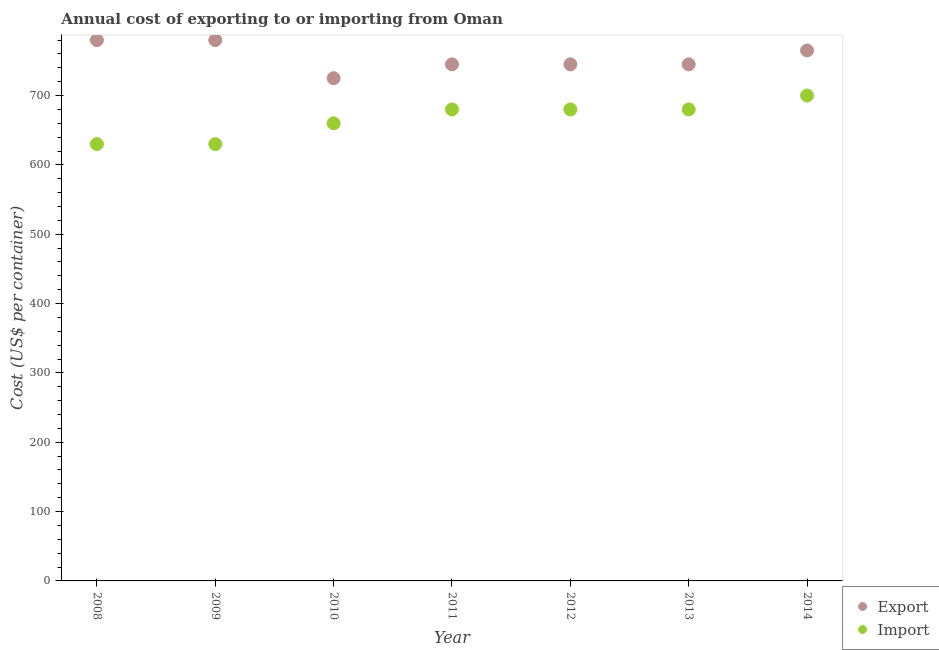How many different coloured dotlines are there?
Offer a very short reply. 2. Is the number of dotlines equal to the number of legend labels?
Your answer should be very brief. Yes. What is the export cost in 2012?
Your response must be concise. 745. Across all years, what is the maximum import cost?
Keep it short and to the point. 700. Across all years, what is the minimum import cost?
Ensure brevity in your answer.  630. In which year was the export cost maximum?
Provide a short and direct response. 2008. In which year was the import cost minimum?
Make the answer very short. 2008. What is the total export cost in the graph?
Ensure brevity in your answer.  5285. What is the difference between the export cost in 2008 and that in 2011?
Keep it short and to the point. 35. What is the difference between the import cost in 2010 and the export cost in 2009?
Give a very brief answer. -120. What is the average import cost per year?
Provide a short and direct response. 665.71. In the year 2008, what is the difference between the export cost and import cost?
Keep it short and to the point. 150. In how many years, is the export cost greater than 440 US$?
Provide a succinct answer. 7. What is the ratio of the export cost in 2009 to that in 2012?
Make the answer very short. 1.05. What is the difference between the highest and the lowest export cost?
Offer a terse response. 55. In how many years, is the export cost greater than the average export cost taken over all years?
Provide a short and direct response. 3. How many years are there in the graph?
Offer a terse response. 7. What is the difference between two consecutive major ticks on the Y-axis?
Ensure brevity in your answer.  100. Are the values on the major ticks of Y-axis written in scientific E-notation?
Provide a succinct answer. No. Does the graph contain any zero values?
Make the answer very short. No. Does the graph contain grids?
Make the answer very short. No. What is the title of the graph?
Keep it short and to the point. Annual cost of exporting to or importing from Oman. What is the label or title of the Y-axis?
Your answer should be compact. Cost (US$ per container). What is the Cost (US$ per container) of Export in 2008?
Keep it short and to the point. 780. What is the Cost (US$ per container) in Import in 2008?
Keep it short and to the point. 630. What is the Cost (US$ per container) of Export in 2009?
Provide a succinct answer. 780. What is the Cost (US$ per container) in Import in 2009?
Your response must be concise. 630. What is the Cost (US$ per container) of Export in 2010?
Ensure brevity in your answer.  725. What is the Cost (US$ per container) of Import in 2010?
Offer a very short reply. 660. What is the Cost (US$ per container) of Export in 2011?
Your answer should be compact. 745. What is the Cost (US$ per container) in Import in 2011?
Provide a short and direct response. 680. What is the Cost (US$ per container) of Export in 2012?
Provide a short and direct response. 745. What is the Cost (US$ per container) of Import in 2012?
Give a very brief answer. 680. What is the Cost (US$ per container) in Export in 2013?
Your answer should be very brief. 745. What is the Cost (US$ per container) of Import in 2013?
Your answer should be compact. 680. What is the Cost (US$ per container) of Export in 2014?
Offer a very short reply. 765. What is the Cost (US$ per container) of Import in 2014?
Make the answer very short. 700. Across all years, what is the maximum Cost (US$ per container) in Export?
Provide a short and direct response. 780. Across all years, what is the maximum Cost (US$ per container) of Import?
Your response must be concise. 700. Across all years, what is the minimum Cost (US$ per container) in Export?
Your answer should be very brief. 725. Across all years, what is the minimum Cost (US$ per container) of Import?
Offer a very short reply. 630. What is the total Cost (US$ per container) in Export in the graph?
Provide a short and direct response. 5285. What is the total Cost (US$ per container) of Import in the graph?
Your response must be concise. 4660. What is the difference between the Cost (US$ per container) of Export in 2008 and that in 2009?
Keep it short and to the point. 0. What is the difference between the Cost (US$ per container) of Export in 2008 and that in 2011?
Ensure brevity in your answer.  35. What is the difference between the Cost (US$ per container) in Import in 2008 and that in 2013?
Provide a short and direct response. -50. What is the difference between the Cost (US$ per container) in Import in 2008 and that in 2014?
Provide a succinct answer. -70. What is the difference between the Cost (US$ per container) of Export in 2009 and that in 2012?
Your response must be concise. 35. What is the difference between the Cost (US$ per container) in Export in 2009 and that in 2013?
Provide a succinct answer. 35. What is the difference between the Cost (US$ per container) in Export in 2009 and that in 2014?
Ensure brevity in your answer.  15. What is the difference between the Cost (US$ per container) in Import in 2009 and that in 2014?
Your answer should be very brief. -70. What is the difference between the Cost (US$ per container) of Export in 2010 and that in 2011?
Give a very brief answer. -20. What is the difference between the Cost (US$ per container) of Import in 2010 and that in 2012?
Make the answer very short. -20. What is the difference between the Cost (US$ per container) of Export in 2010 and that in 2013?
Make the answer very short. -20. What is the difference between the Cost (US$ per container) in Import in 2010 and that in 2013?
Keep it short and to the point. -20. What is the difference between the Cost (US$ per container) in Import in 2011 and that in 2012?
Provide a succinct answer. 0. What is the difference between the Cost (US$ per container) of Import in 2011 and that in 2013?
Make the answer very short. 0. What is the difference between the Cost (US$ per container) of Export in 2011 and that in 2014?
Your answer should be very brief. -20. What is the difference between the Cost (US$ per container) in Export in 2012 and that in 2013?
Provide a succinct answer. 0. What is the difference between the Cost (US$ per container) in Export in 2012 and that in 2014?
Provide a short and direct response. -20. What is the difference between the Cost (US$ per container) of Export in 2013 and that in 2014?
Keep it short and to the point. -20. What is the difference between the Cost (US$ per container) in Import in 2013 and that in 2014?
Give a very brief answer. -20. What is the difference between the Cost (US$ per container) of Export in 2008 and the Cost (US$ per container) of Import in 2009?
Ensure brevity in your answer.  150. What is the difference between the Cost (US$ per container) in Export in 2008 and the Cost (US$ per container) in Import in 2010?
Your answer should be very brief. 120. What is the difference between the Cost (US$ per container) in Export in 2008 and the Cost (US$ per container) in Import in 2012?
Keep it short and to the point. 100. What is the difference between the Cost (US$ per container) in Export in 2009 and the Cost (US$ per container) in Import in 2010?
Give a very brief answer. 120. What is the difference between the Cost (US$ per container) in Export in 2009 and the Cost (US$ per container) in Import in 2014?
Give a very brief answer. 80. What is the difference between the Cost (US$ per container) of Export in 2010 and the Cost (US$ per container) of Import in 2013?
Provide a succinct answer. 45. What is the difference between the Cost (US$ per container) in Export in 2011 and the Cost (US$ per container) in Import in 2014?
Give a very brief answer. 45. What is the difference between the Cost (US$ per container) in Export in 2012 and the Cost (US$ per container) in Import in 2014?
Keep it short and to the point. 45. What is the difference between the Cost (US$ per container) in Export in 2013 and the Cost (US$ per container) in Import in 2014?
Keep it short and to the point. 45. What is the average Cost (US$ per container) of Export per year?
Make the answer very short. 755. What is the average Cost (US$ per container) of Import per year?
Offer a terse response. 665.71. In the year 2008, what is the difference between the Cost (US$ per container) of Export and Cost (US$ per container) of Import?
Keep it short and to the point. 150. In the year 2009, what is the difference between the Cost (US$ per container) of Export and Cost (US$ per container) of Import?
Offer a very short reply. 150. In the year 2011, what is the difference between the Cost (US$ per container) in Export and Cost (US$ per container) in Import?
Your answer should be compact. 65. In the year 2012, what is the difference between the Cost (US$ per container) in Export and Cost (US$ per container) in Import?
Provide a short and direct response. 65. In the year 2013, what is the difference between the Cost (US$ per container) in Export and Cost (US$ per container) in Import?
Keep it short and to the point. 65. In the year 2014, what is the difference between the Cost (US$ per container) of Export and Cost (US$ per container) of Import?
Your answer should be compact. 65. What is the ratio of the Cost (US$ per container) in Export in 2008 to that in 2010?
Provide a short and direct response. 1.08. What is the ratio of the Cost (US$ per container) of Import in 2008 to that in 2010?
Provide a succinct answer. 0.95. What is the ratio of the Cost (US$ per container) in Export in 2008 to that in 2011?
Your response must be concise. 1.05. What is the ratio of the Cost (US$ per container) in Import in 2008 to that in 2011?
Your response must be concise. 0.93. What is the ratio of the Cost (US$ per container) in Export in 2008 to that in 2012?
Your answer should be compact. 1.05. What is the ratio of the Cost (US$ per container) in Import in 2008 to that in 2012?
Keep it short and to the point. 0.93. What is the ratio of the Cost (US$ per container) of Export in 2008 to that in 2013?
Offer a terse response. 1.05. What is the ratio of the Cost (US$ per container) of Import in 2008 to that in 2013?
Your answer should be compact. 0.93. What is the ratio of the Cost (US$ per container) of Export in 2008 to that in 2014?
Keep it short and to the point. 1.02. What is the ratio of the Cost (US$ per container) of Export in 2009 to that in 2010?
Provide a succinct answer. 1.08. What is the ratio of the Cost (US$ per container) in Import in 2009 to that in 2010?
Provide a short and direct response. 0.95. What is the ratio of the Cost (US$ per container) of Export in 2009 to that in 2011?
Provide a short and direct response. 1.05. What is the ratio of the Cost (US$ per container) of Import in 2009 to that in 2011?
Your answer should be compact. 0.93. What is the ratio of the Cost (US$ per container) in Export in 2009 to that in 2012?
Give a very brief answer. 1.05. What is the ratio of the Cost (US$ per container) of Import in 2009 to that in 2012?
Keep it short and to the point. 0.93. What is the ratio of the Cost (US$ per container) of Export in 2009 to that in 2013?
Make the answer very short. 1.05. What is the ratio of the Cost (US$ per container) in Import in 2009 to that in 2013?
Your response must be concise. 0.93. What is the ratio of the Cost (US$ per container) in Export in 2009 to that in 2014?
Make the answer very short. 1.02. What is the ratio of the Cost (US$ per container) in Import in 2009 to that in 2014?
Provide a short and direct response. 0.9. What is the ratio of the Cost (US$ per container) in Export in 2010 to that in 2011?
Give a very brief answer. 0.97. What is the ratio of the Cost (US$ per container) of Import in 2010 to that in 2011?
Ensure brevity in your answer.  0.97. What is the ratio of the Cost (US$ per container) in Export in 2010 to that in 2012?
Your response must be concise. 0.97. What is the ratio of the Cost (US$ per container) of Import in 2010 to that in 2012?
Offer a terse response. 0.97. What is the ratio of the Cost (US$ per container) of Export in 2010 to that in 2013?
Your answer should be very brief. 0.97. What is the ratio of the Cost (US$ per container) of Import in 2010 to that in 2013?
Offer a very short reply. 0.97. What is the ratio of the Cost (US$ per container) in Export in 2010 to that in 2014?
Your answer should be compact. 0.95. What is the ratio of the Cost (US$ per container) in Import in 2010 to that in 2014?
Make the answer very short. 0.94. What is the ratio of the Cost (US$ per container) of Export in 2011 to that in 2012?
Provide a short and direct response. 1. What is the ratio of the Cost (US$ per container) of Import in 2011 to that in 2012?
Provide a succinct answer. 1. What is the ratio of the Cost (US$ per container) of Import in 2011 to that in 2013?
Your answer should be compact. 1. What is the ratio of the Cost (US$ per container) of Export in 2011 to that in 2014?
Offer a terse response. 0.97. What is the ratio of the Cost (US$ per container) of Import in 2011 to that in 2014?
Your answer should be compact. 0.97. What is the ratio of the Cost (US$ per container) of Export in 2012 to that in 2013?
Provide a succinct answer. 1. What is the ratio of the Cost (US$ per container) of Import in 2012 to that in 2013?
Provide a succinct answer. 1. What is the ratio of the Cost (US$ per container) of Export in 2012 to that in 2014?
Make the answer very short. 0.97. What is the ratio of the Cost (US$ per container) of Import in 2012 to that in 2014?
Provide a succinct answer. 0.97. What is the ratio of the Cost (US$ per container) in Export in 2013 to that in 2014?
Your response must be concise. 0.97. What is the ratio of the Cost (US$ per container) of Import in 2013 to that in 2014?
Ensure brevity in your answer.  0.97. What is the difference between the highest and the second highest Cost (US$ per container) in Import?
Your response must be concise. 20. What is the difference between the highest and the lowest Cost (US$ per container) of Export?
Offer a terse response. 55. 